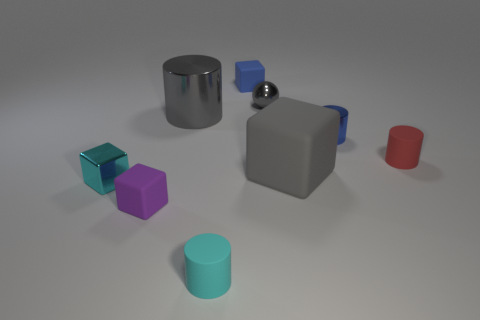Subtract all red cylinders. Subtract all yellow cubes. How many cylinders are left? 3 Subtract all spheres. How many objects are left? 8 Add 1 tiny red cylinders. How many tiny red cylinders are left? 2 Add 2 big metallic things. How many big metallic things exist? 3 Subtract 1 red cylinders. How many objects are left? 8 Subtract all tiny purple cubes. Subtract all metal objects. How many objects are left? 4 